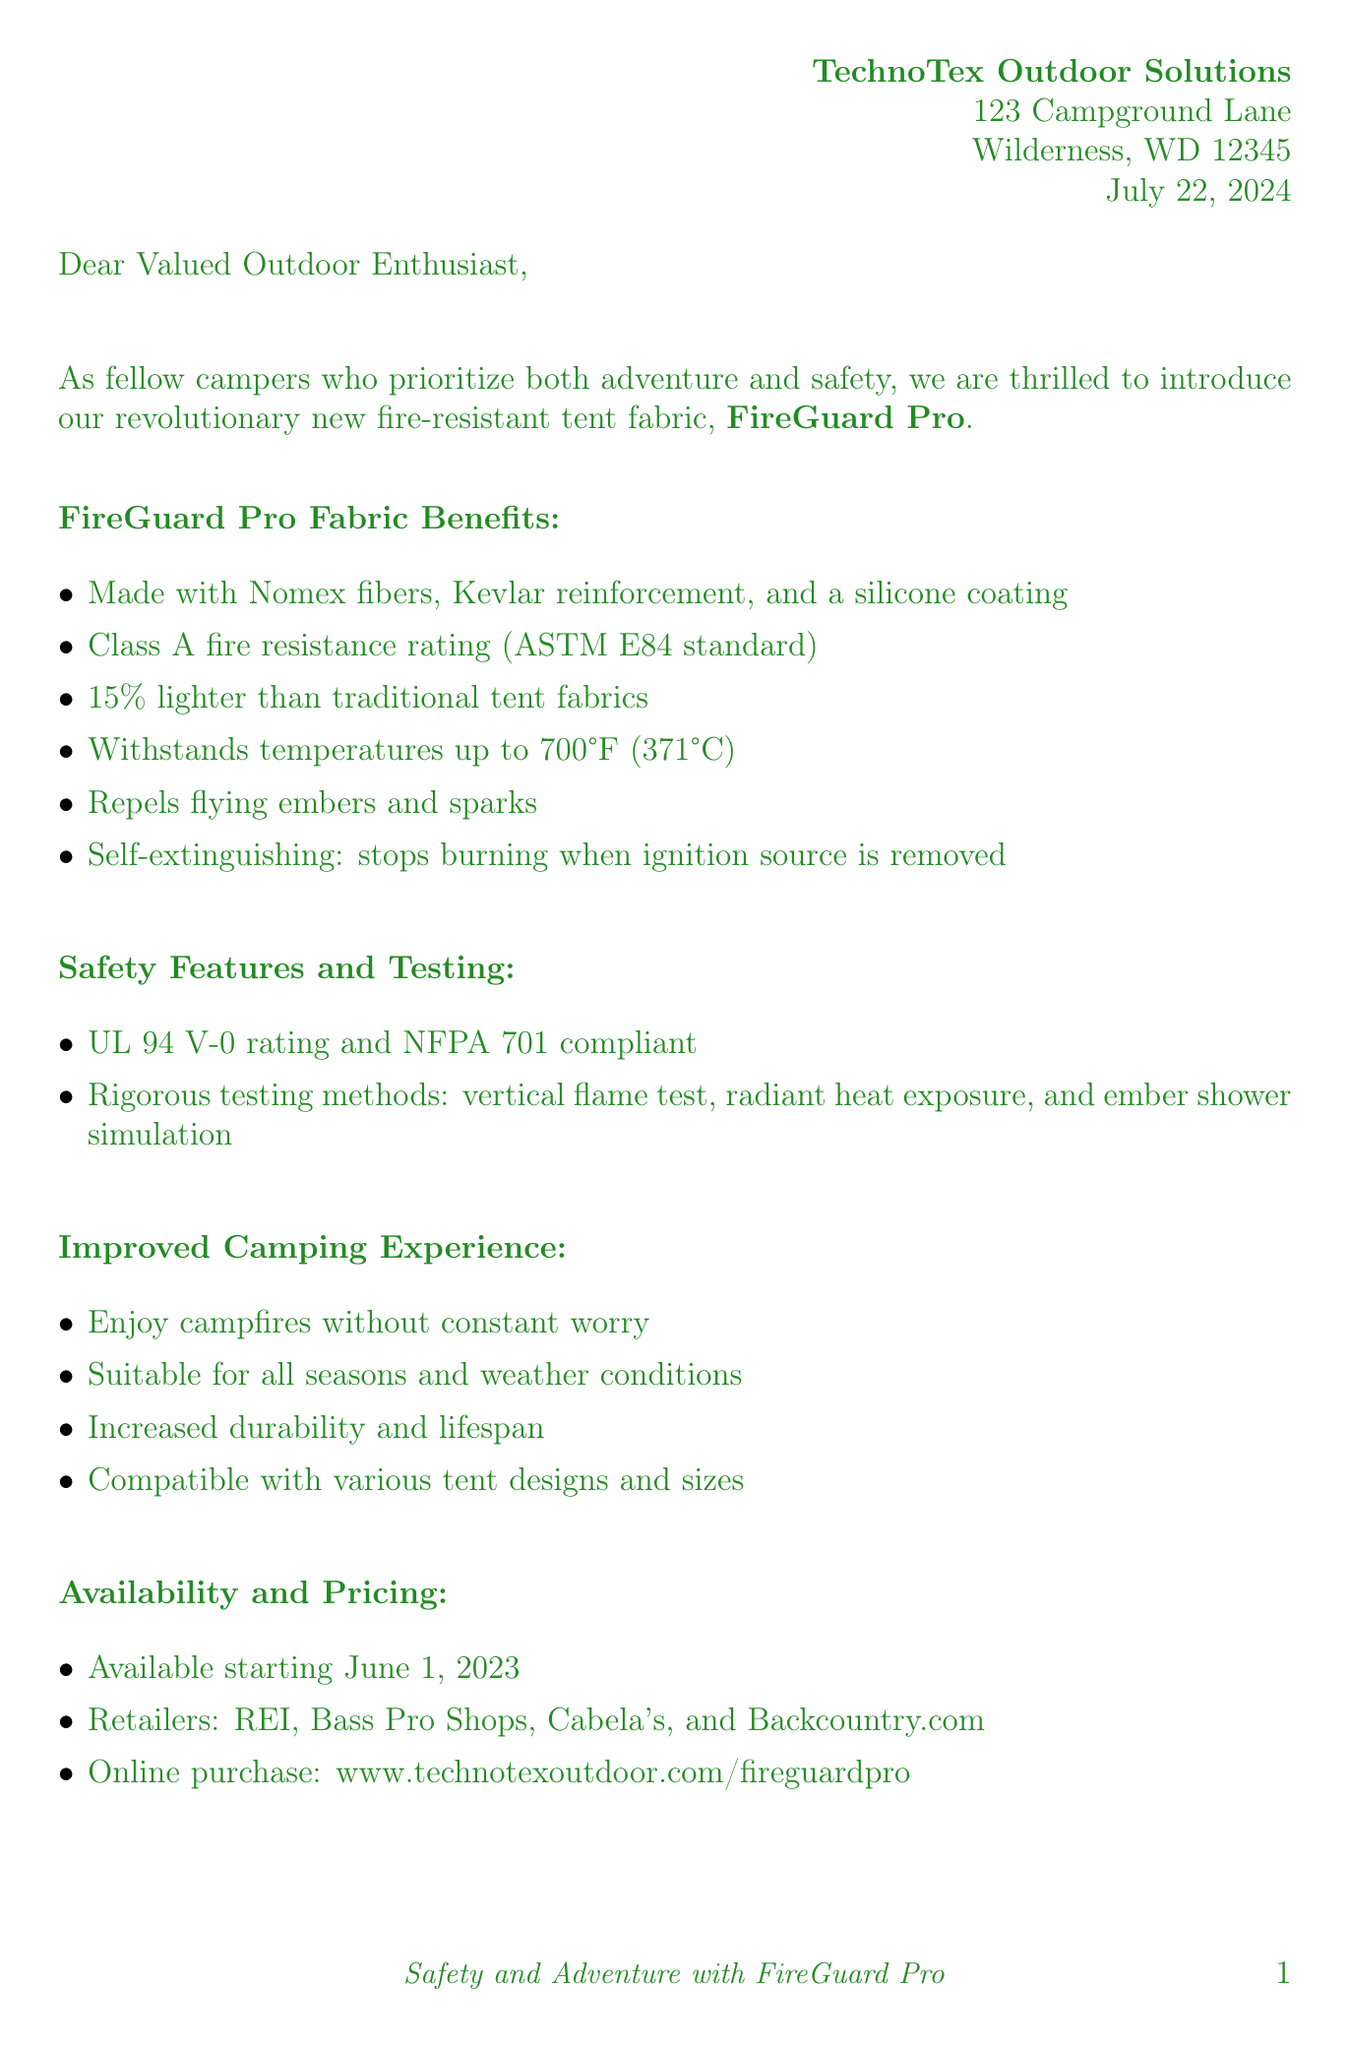What is the name of the new fabric introduced? The document introduces a new fabric named FireGuard Pro.
Answer: FireGuard Pro What temperature can the fabric withstand? The fabric can withstand temperatures up to 700°F (371°C).
Answer: 700°F (371°C) How much does the 4-person tent cost? The price for the 4-person tent is listed in the pricing section as $449.99.
Answer: $449.99 What are the materials used in FireGuard Pro? The fabric is made from Nomex fibers, Kevlar reinforcement, and a silicone coating.
Answer: Nomex fibers, Kevlar reinforcement, silicone coating When will FireGuard Pro be available? The document states that FireGuard Pro will be available starting June 1, 2023.
Answer: June 1, 2023 What is one key benefit of using FireGuard Pro while camping? One key benefit is that it allows campers to enjoy campfires without constant worry.
Answer: Enjoy campfires without constant worry Which retailers will carry the new fabric? The document lists REI, Bass Pro Shops, Cabela's, and Backcountry.com as retailers.
Answer: REI, Bass Pro Shops, Cabela's, Backcountry.com Who provides a testimonial about FireGuard Pro? The testimonial in the document is provided by Sarah Johnson, a Wilderness Guide.
Answer: Sarah Johnson What is emphasized at the end of the letter? The end of the letter emphasizes practicing proper fire safety.
Answer: Proper fire safety 